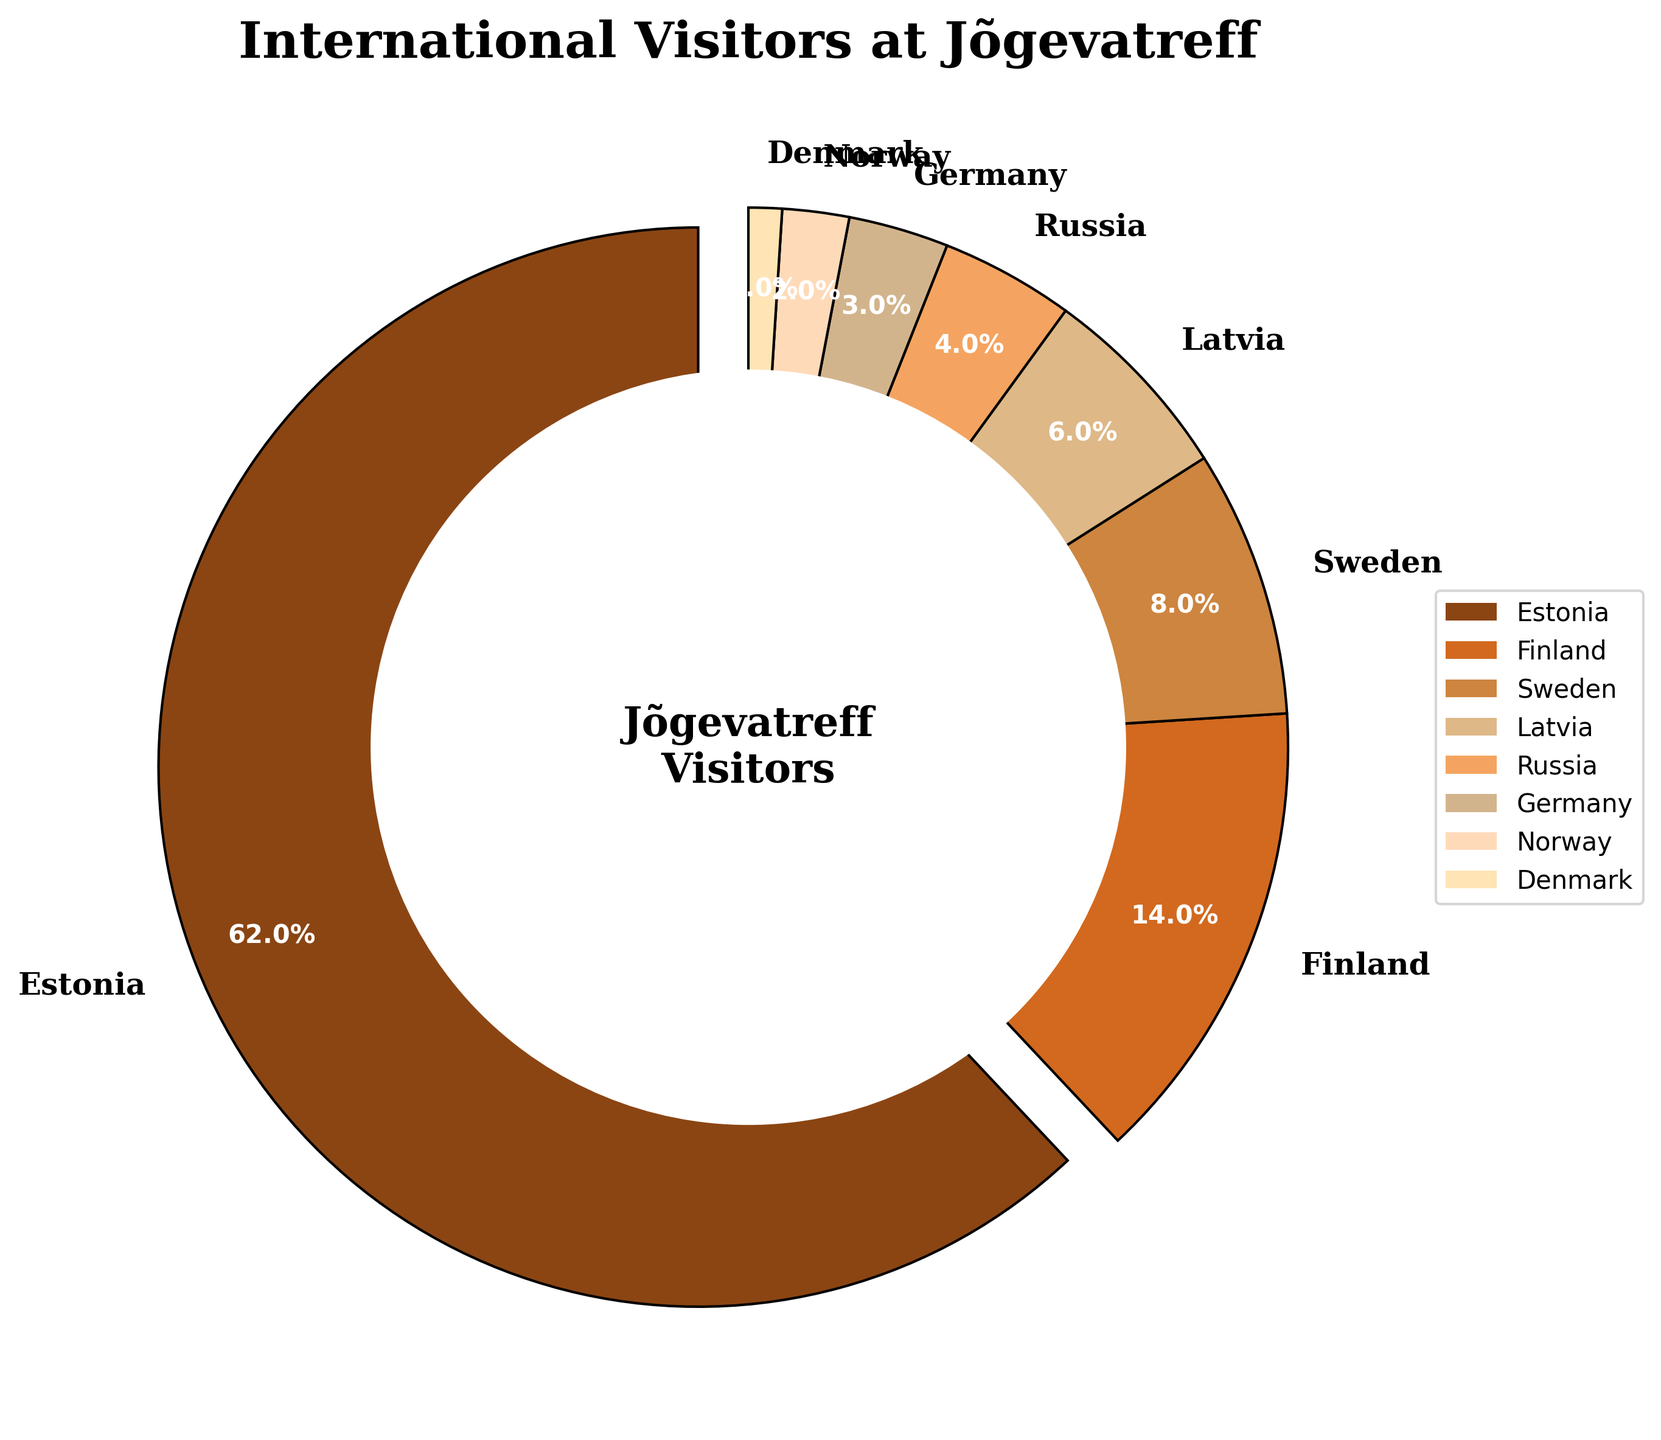What's the percentage of visitors from Finland and Sweden combined? We need to sum the percentages of visitors from Finland and Sweden. According to the data, Finland has 14% and Sweden has 8%. 14 + 8 = 22
Answer: 22% Which country has the second highest percentage of visitors? To answer this, we need to identify which percentage value is the second highest in the list. Estonia has the highest with 62%, and Finland follows with 14%.
Answer: Finland How many more percentage points do Estonian visitors represent compared to Latvian visitors? To find the difference, we subtract the percentage of Latvian visitors from the percentage of Estonian visitors. Estonia has 62%, and Latvia has 6%. 62 - 6 = 56
Answer: 56 Are there more visitors from Sweden or Russia? Checking the data, Sweden has 8% and Russia has 4%. 8% is greater than 4%.
Answer: Sweden If we look at the pie segments, which segment is the smallest and what percentage does it represent? The smallest segment corresponds to the country with the smallest percentage. According to the data, Denmark has the smallest percentage with 1%.
Answer: Denmark, 1% What is the combined percentage of visitors from countries with less than 5% representation? Adding the percentages of countries with less than 5%: Russia (4%), Germany (3%), Norway (2%), Denmark (1%). 4 + 3 + 2 + 1 = 10
Answer: 10% Which country represents more visitors, Germany or Norway? Comparing the percentages, Germany has 3% and Norway has 2%. 3% is greater than 2%.
Answer: Germany What visual attributes indicate the country with the largest percentage of visitors? The largest segment in the pie chart is usually larger in area, more prominently colored, often with a label, and a percentage value. Estonia, represented by the largest segment (62%), has its segment slightly exploded outward.
Answer: Estonia How does the percentage of Norwegian visitors compare to Finnish visitors? Comparing the percentages, Norway has 2% and Finland has 14%. 2% is less than 14%.
Answer: Less than 14% What percentage of the visitors comes from countries starting with 'S'? Adding the percentages of Sweden (8%) and Russia (4%) since Russia in Estonian is 'Venemaa' and Sweden starts with 'S'. 8 + 0 = 8
Answer: 8% 